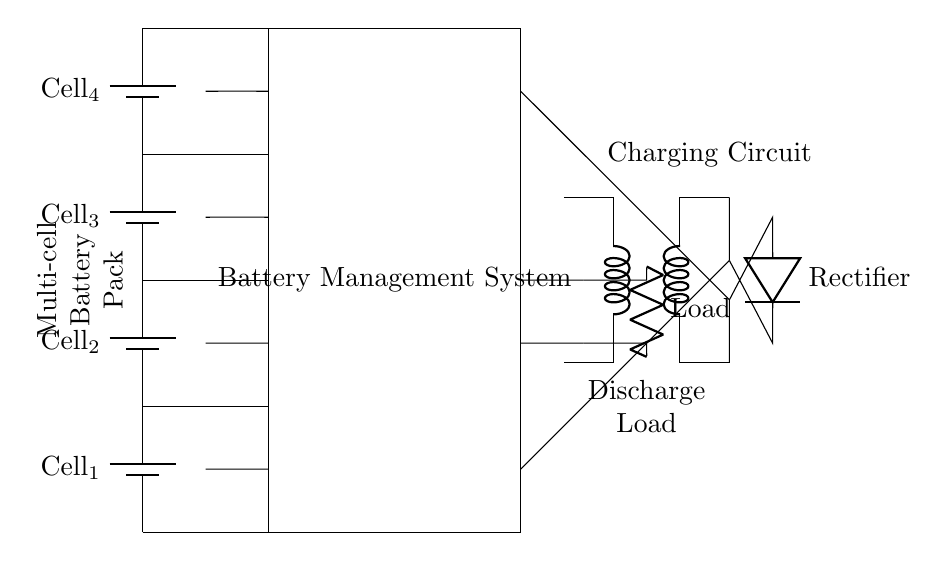What are the individual cell components used in the circuit? The circuit contains four battery cells labeled as Cell 1, Cell 2, Cell 3, and Cell 4, connected in series.
Answer: Cell 1, Cell 2, Cell 3, Cell 4 What type of system is used for monitoring? The circuit incorporates a Battery Management System (BMS) that monitors the voltage and temperature of individual cells.
Answer: Battery Management System How many temperature sensors are present in the circuit? There are four thermistors acting as temperature sensors, each corresponding to one of the battery cells.
Answer: Four What is the purpose of the transformer in this circuit? The transformer is used to step down the voltage from the charger to suitable levels for the battery management and charging of the battery cells.
Answer: Step down voltage What are the connections from the battery management system to the charger? The connections include a wire from the upper part of the BMS to the positive terminal of the charger and one from the lower part to the negative terminal.
Answer: Positive and negative connections Why is individual cell monitoring critical in this setup? Individual cell monitoring allows for detecting imbalances in voltage, which helps prevent overcharging and enhances safety and battery longevity.
Answer: Prevents overcharging What type of load is represented in the circuit? The load in the circuit is represented by a resistor labeled as Load, indicating it is a resistive load that the battery system can power.
Answer: Resistor 